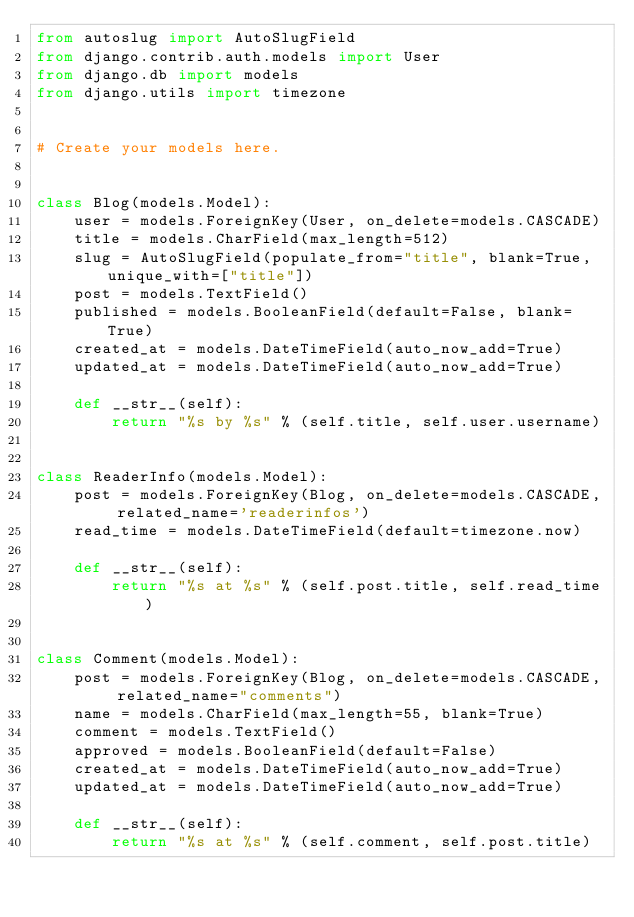Convert code to text. <code><loc_0><loc_0><loc_500><loc_500><_Python_>from autoslug import AutoSlugField
from django.contrib.auth.models import User
from django.db import models
from django.utils import timezone


# Create your models here.


class Blog(models.Model):
    user = models.ForeignKey(User, on_delete=models.CASCADE)
    title = models.CharField(max_length=512)
    slug = AutoSlugField(populate_from="title", blank=True, unique_with=["title"])
    post = models.TextField()
    published = models.BooleanField(default=False, blank=True)
    created_at = models.DateTimeField(auto_now_add=True)
    updated_at = models.DateTimeField(auto_now_add=True)

    def __str__(self):
        return "%s by %s" % (self.title, self.user.username)


class ReaderInfo(models.Model):
    post = models.ForeignKey(Blog, on_delete=models.CASCADE, related_name='readerinfos')
    read_time = models.DateTimeField(default=timezone.now)

    def __str__(self):
        return "%s at %s" % (self.post.title, self.read_time)


class Comment(models.Model):
    post = models.ForeignKey(Blog, on_delete=models.CASCADE, related_name="comments")
    name = models.CharField(max_length=55, blank=True)
    comment = models.TextField()
    approved = models.BooleanField(default=False)
    created_at = models.DateTimeField(auto_now_add=True)
    updated_at = models.DateTimeField(auto_now_add=True)

    def __str__(self):
        return "%s at %s" % (self.comment, self.post.title)
</code> 